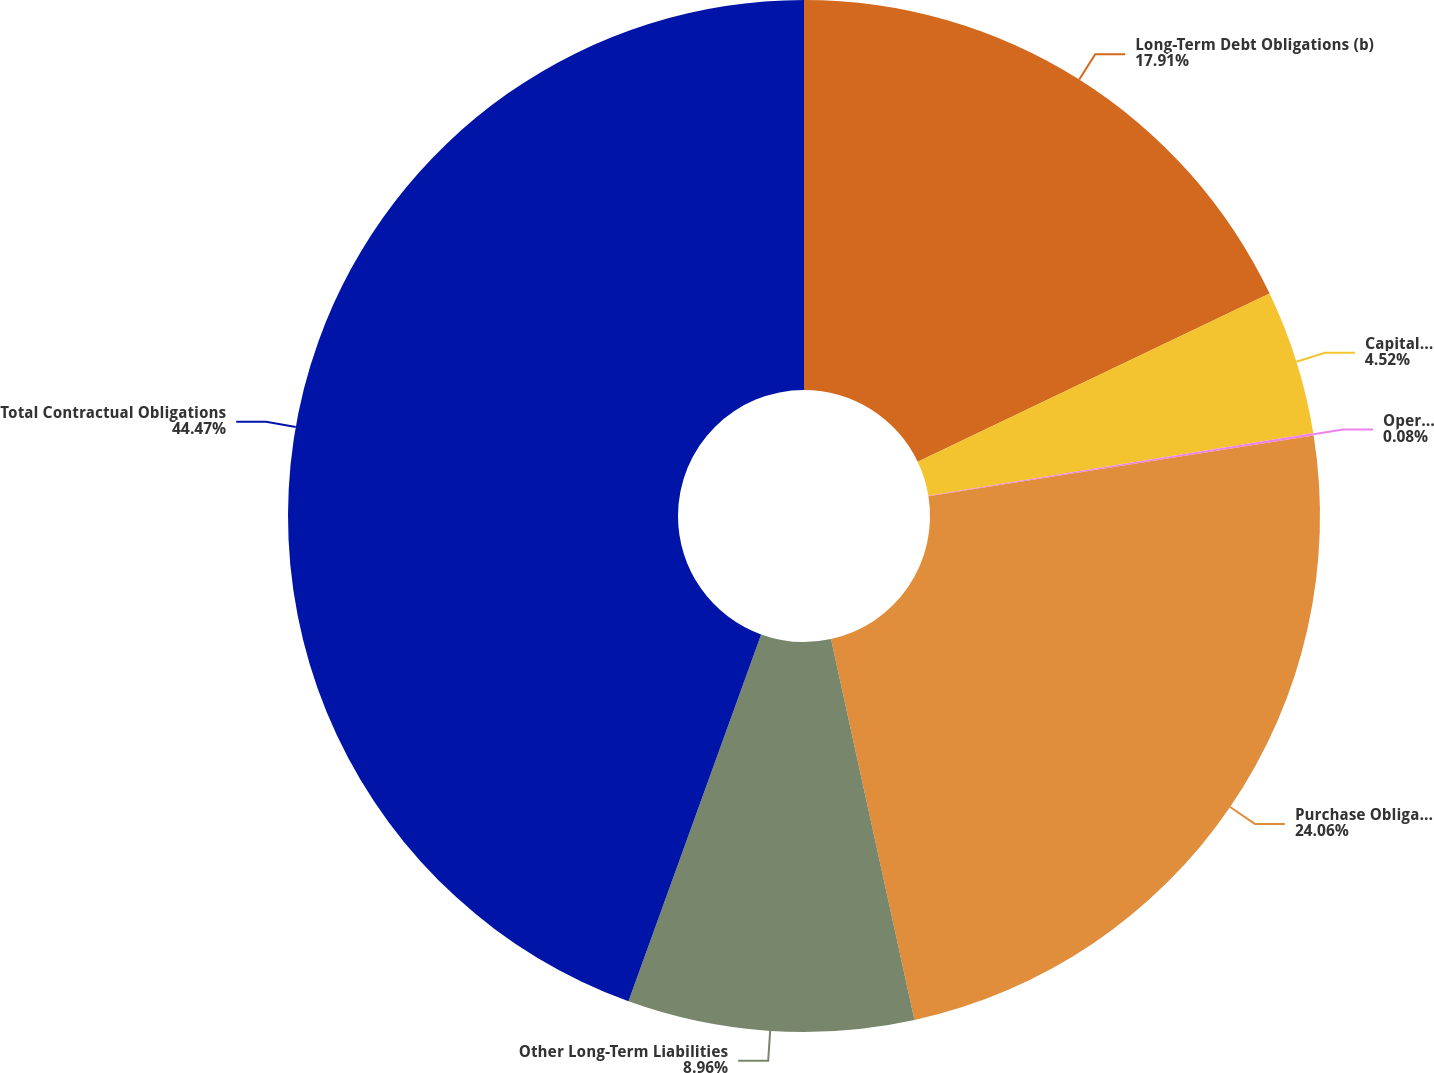<chart> <loc_0><loc_0><loc_500><loc_500><pie_chart><fcel>Long-Term Debt Obligations (b)<fcel>Capital Lease Obligations (c)<fcel>Operating Lease Obligations<fcel>Purchase Obligations (e)<fcel>Other Long-Term Liabilities<fcel>Total Contractual Obligations<nl><fcel>17.91%<fcel>4.52%<fcel>0.08%<fcel>24.06%<fcel>8.96%<fcel>44.48%<nl></chart> 